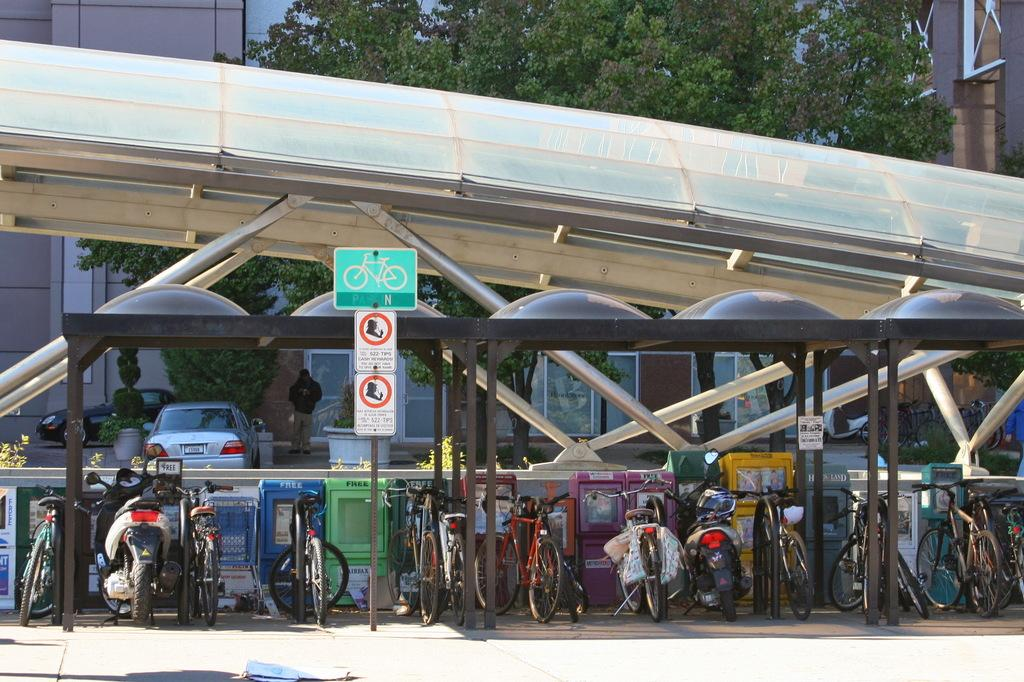What type of stands are located in the front of the image? There is a cycle stand and a scooter stand in the front of the image. What is the color and material of the shed in the image? The shed is white and made of metal. What can be seen in the background of the image? There are trees and buildings in the background of the image. How many cows are grazing in the image? There are no cows present in the image. Is there a pancake being served in the image? There is no pancake visible in the image. 